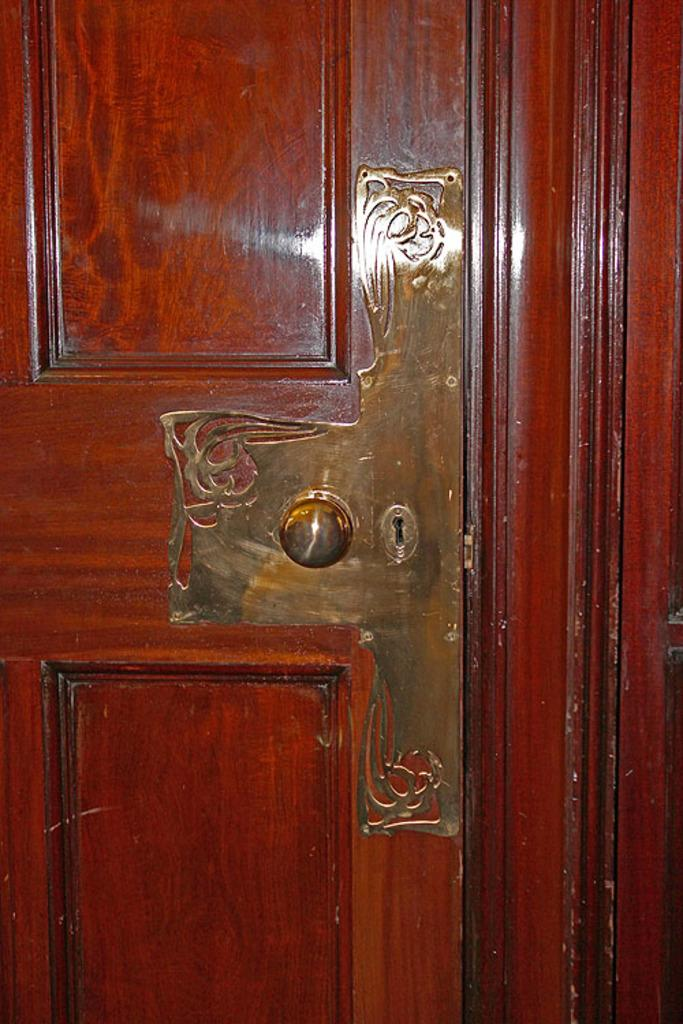What is a prominent feature in the image? There is a door in the image. What part of the door is used for opening and closing it? There is a door handle on the door. How many kittens are sitting inside the jar in the image? There are no kittens or jars present in the image. 